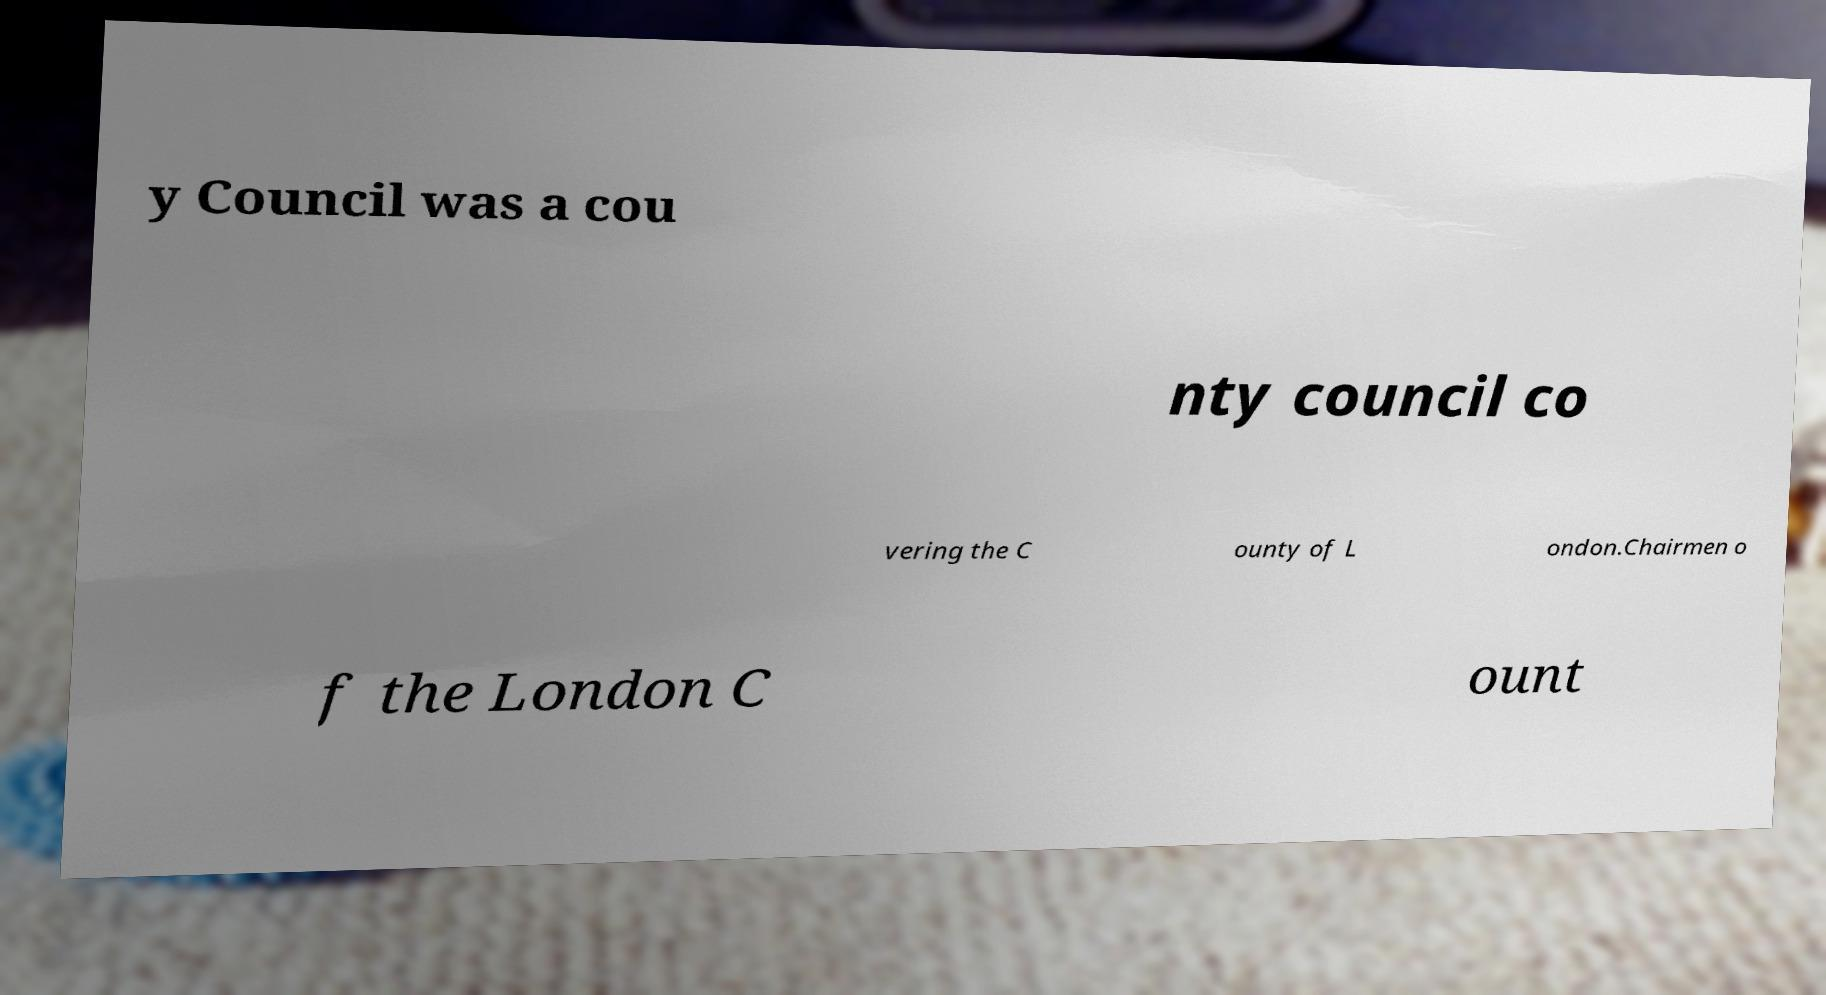Please read and relay the text visible in this image. What does it say? y Council was a cou nty council co vering the C ounty of L ondon.Chairmen o f the London C ount 